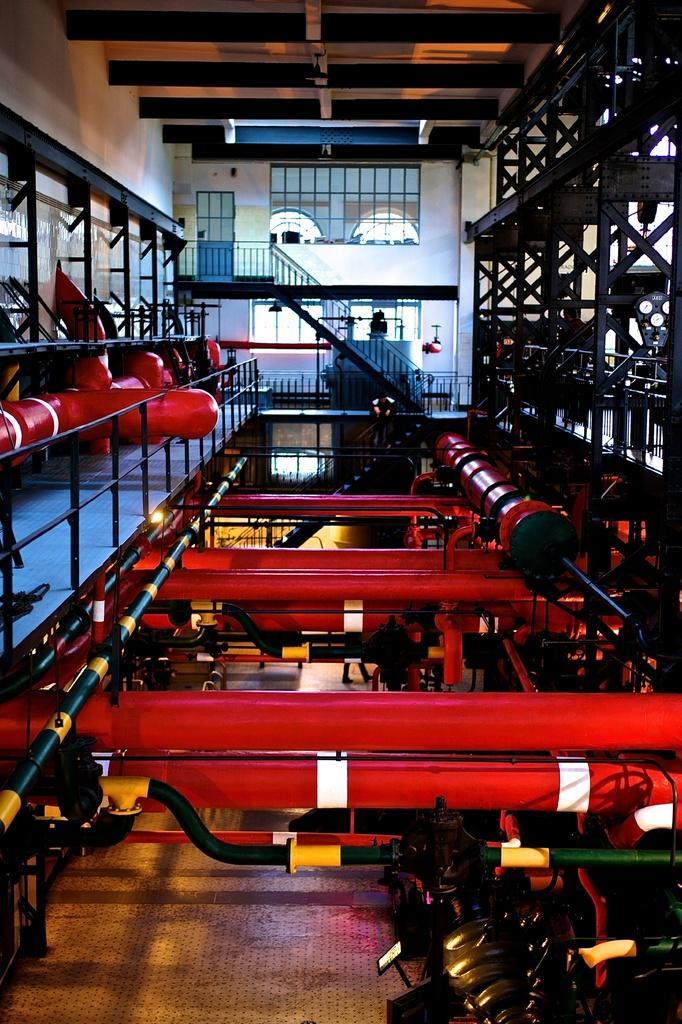Please provide a concise description of this image. This picture is an inside view of a building. In this picture we can see the machines, rods, railing. In the center of the image we can see the wall, stairs, door, windows. At the top of the image we can see the roof. At the bottom of the image we can see the floor. 